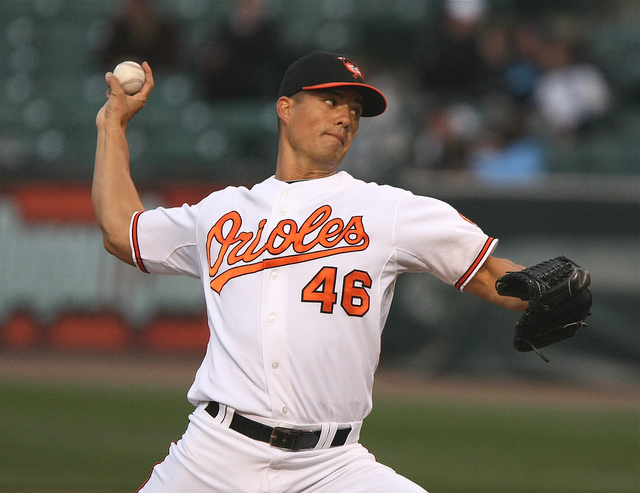Extract all visible text content from this image. Ozioles 46 46 